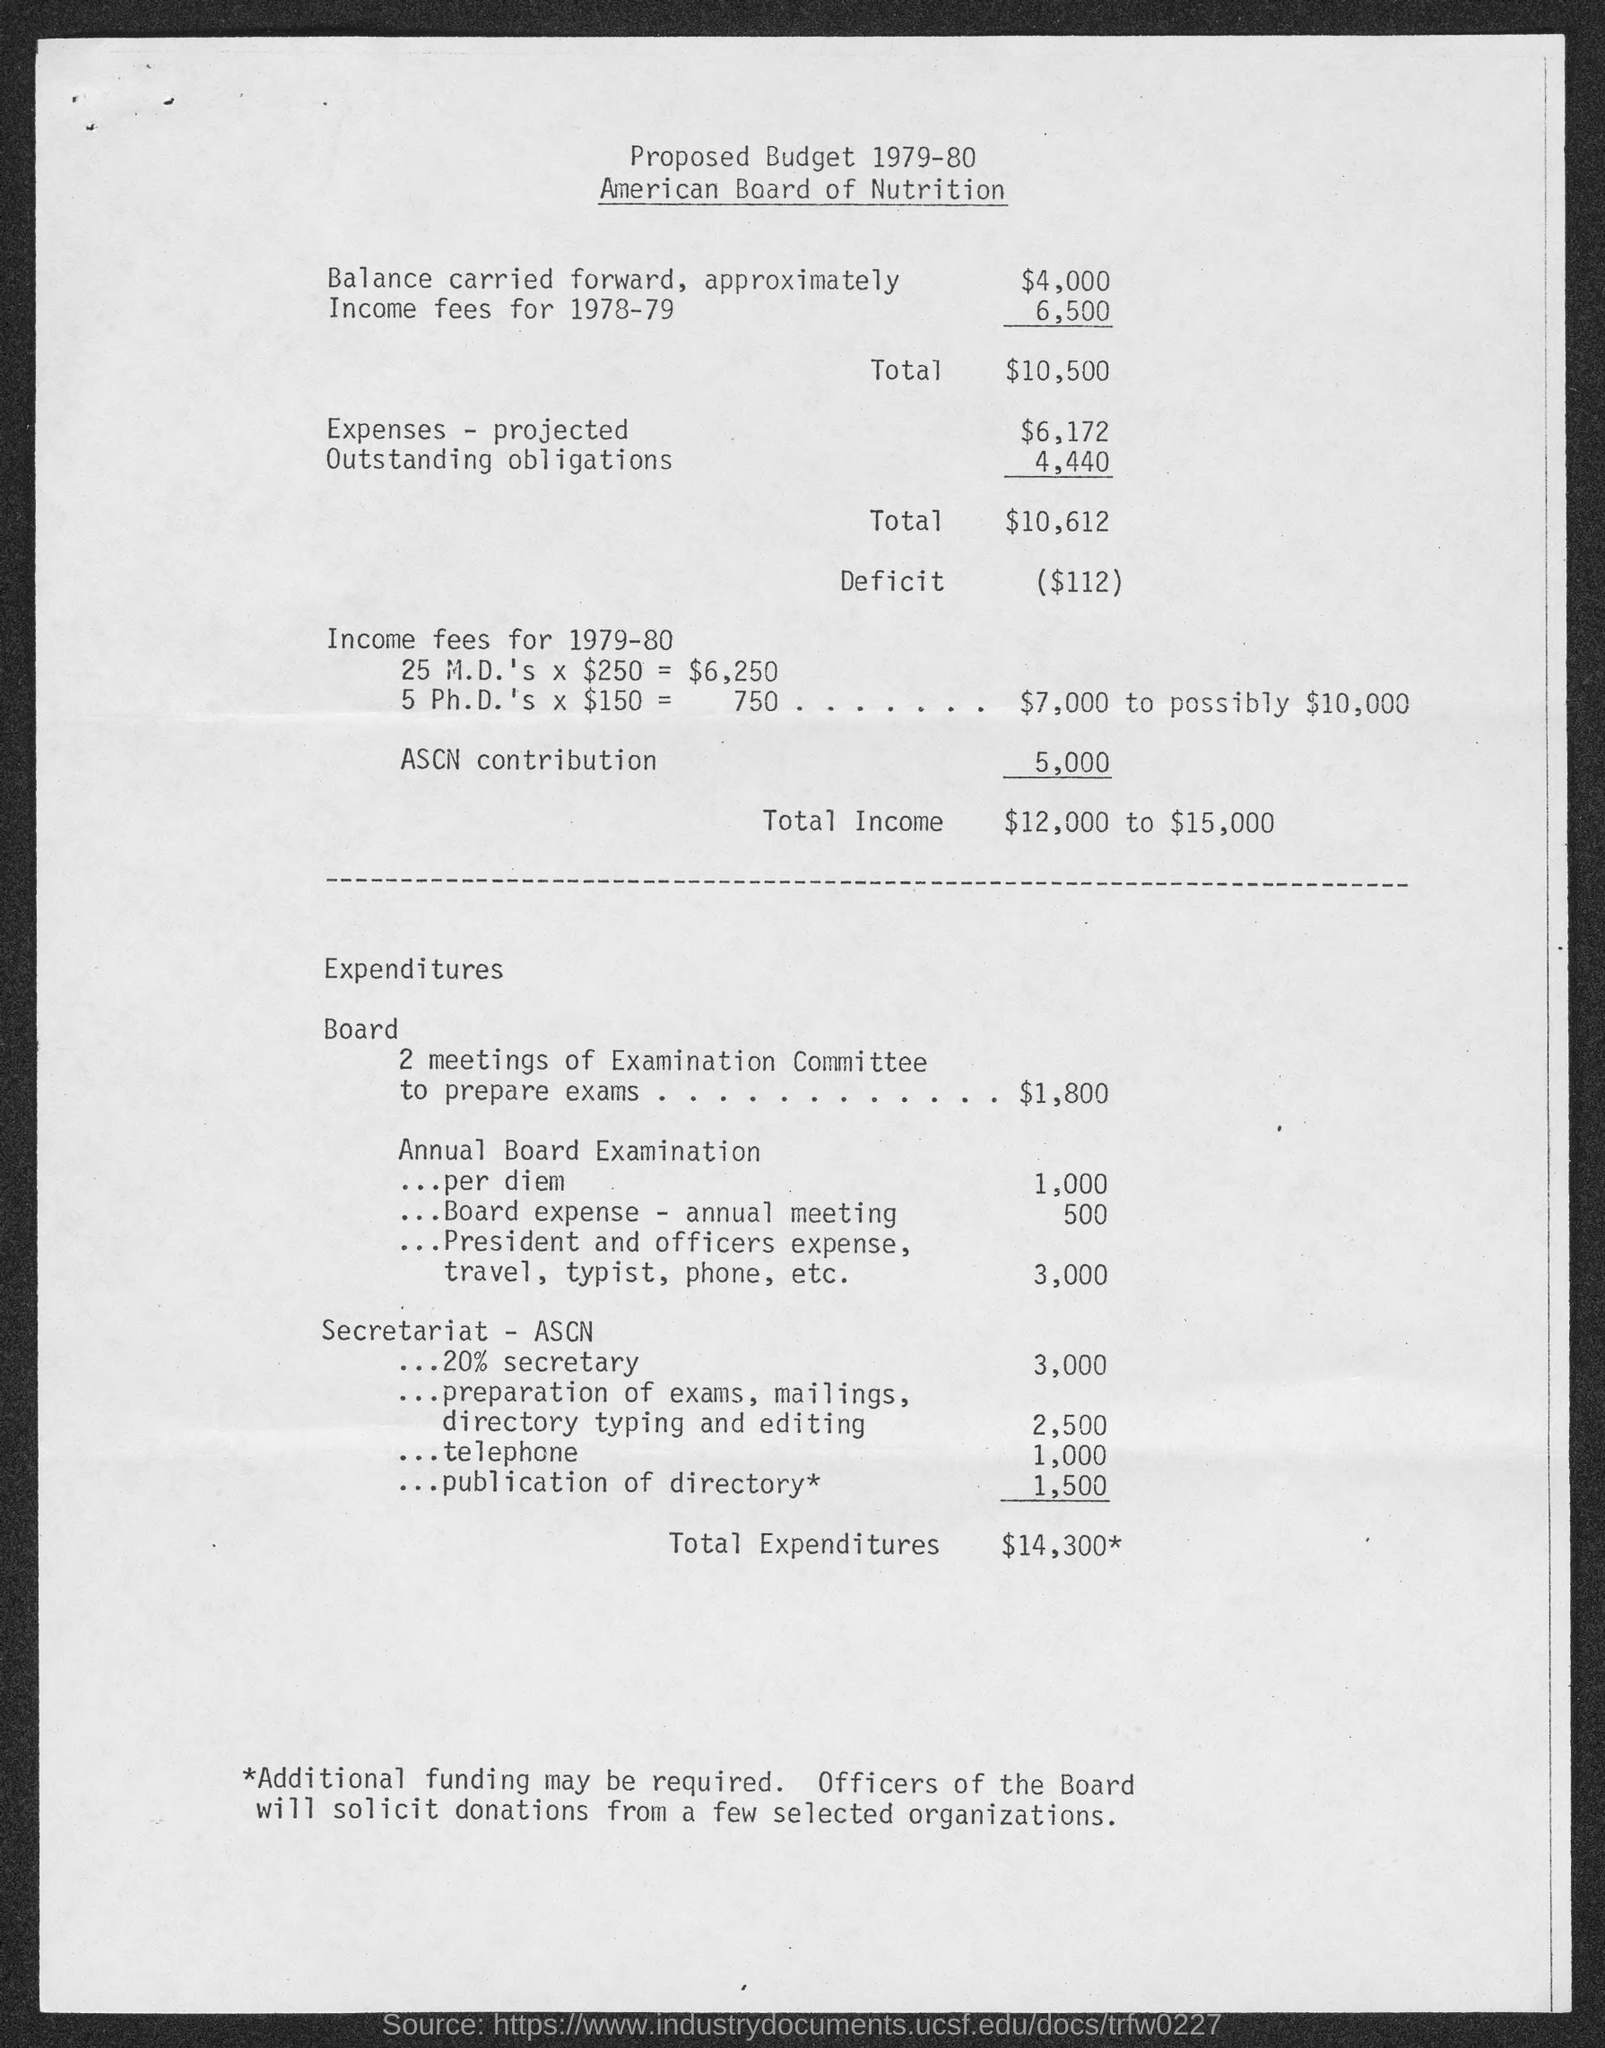Give some essential details in this illustration. The total expenditures amounted to $14,300. The total income ranges from $12,000 to $15,000. 